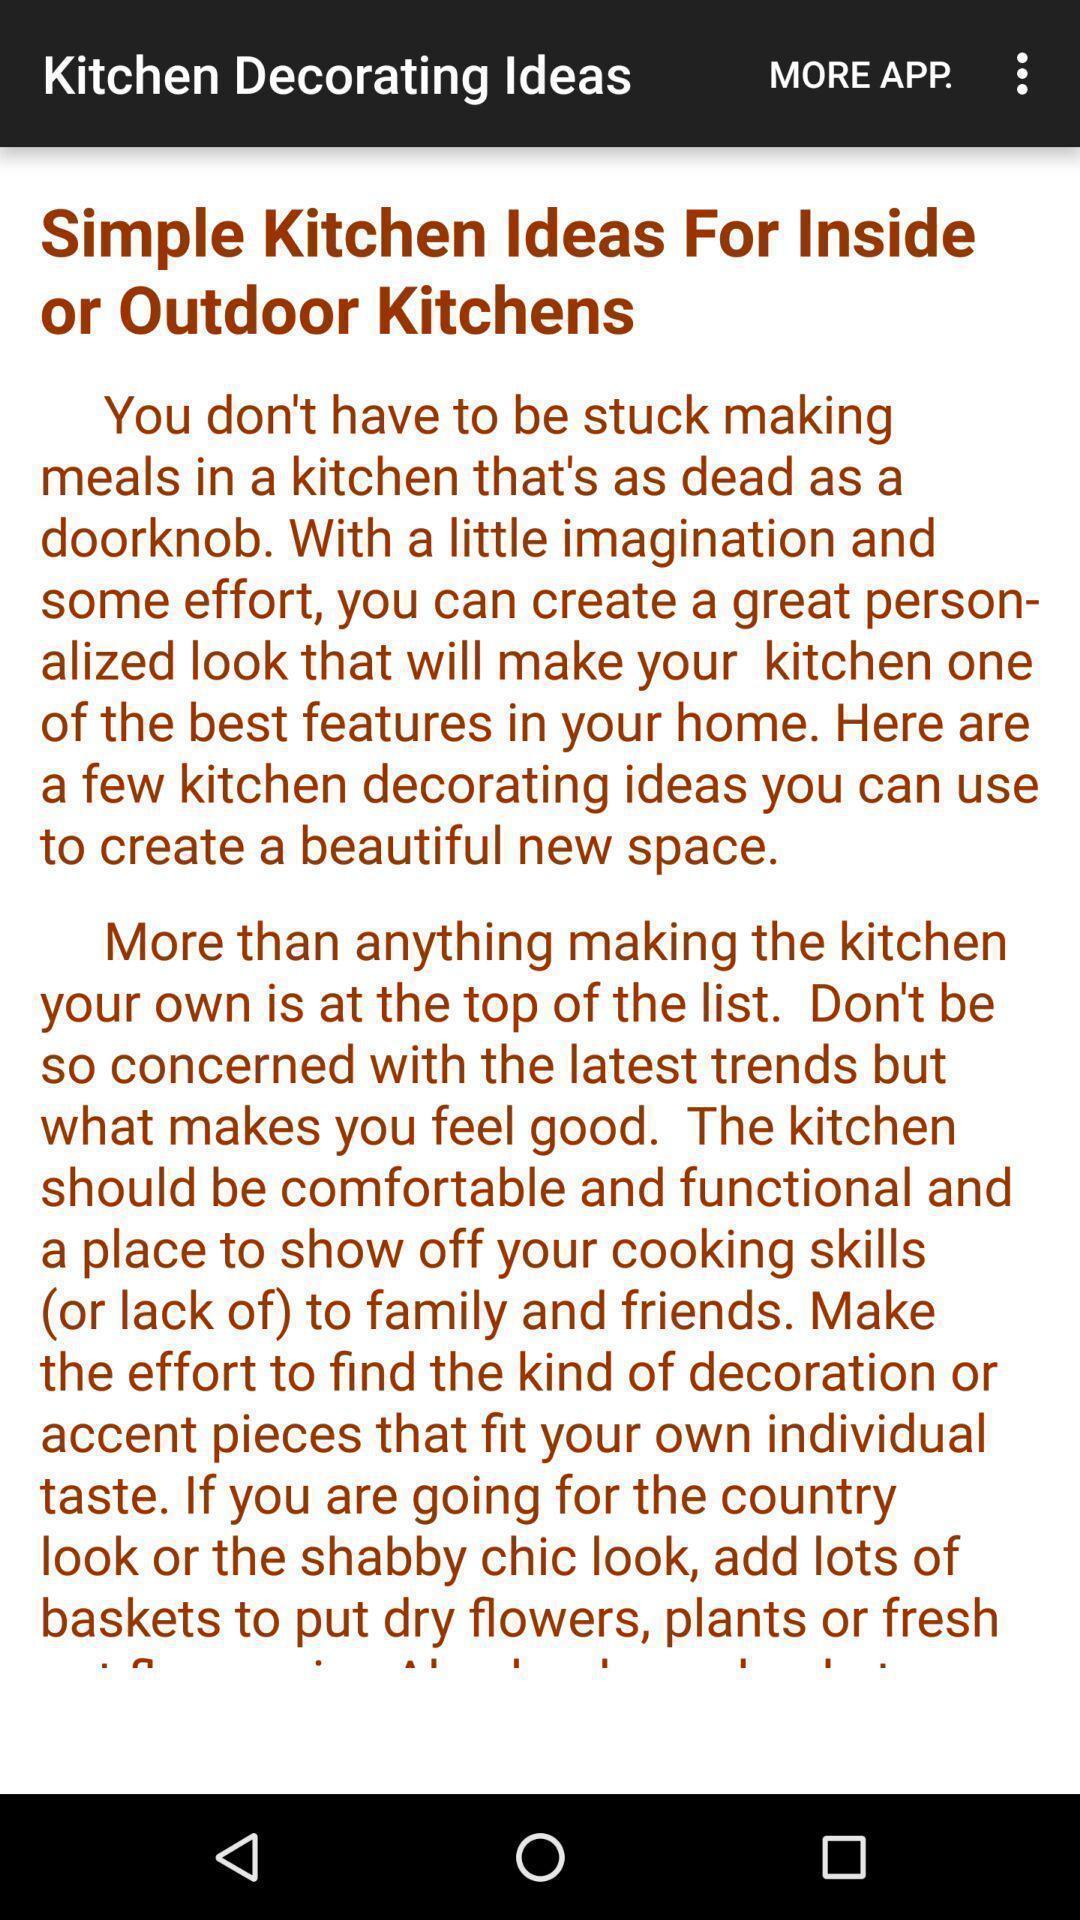Describe this image in words. Page of kitchen decorating ideas in the app. 